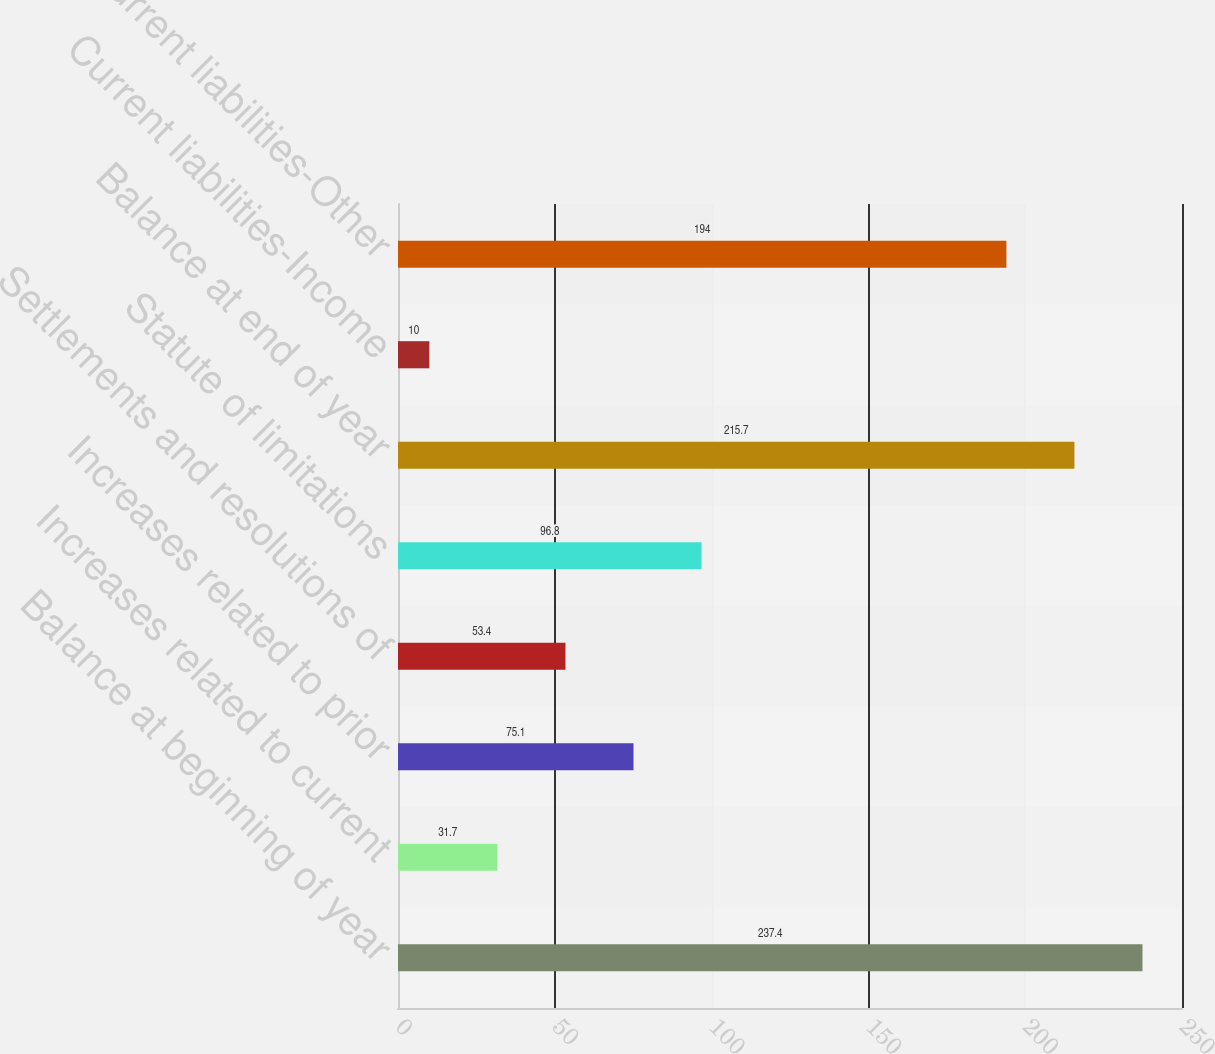Convert chart. <chart><loc_0><loc_0><loc_500><loc_500><bar_chart><fcel>Balance at beginning of year<fcel>Increases related to current<fcel>Increases related to prior<fcel>Settlements and resolutions of<fcel>Statute of limitations<fcel>Balance at end of year<fcel>Current liabilities-Income<fcel>Noncurrent liabilities-Other<nl><fcel>237.4<fcel>31.7<fcel>75.1<fcel>53.4<fcel>96.8<fcel>215.7<fcel>10<fcel>194<nl></chart> 